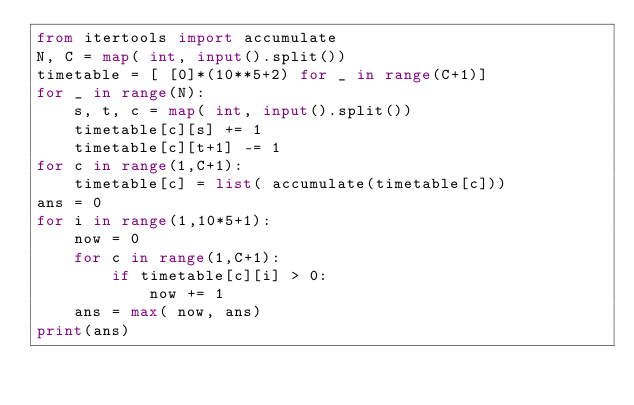Convert code to text. <code><loc_0><loc_0><loc_500><loc_500><_Python_>from itertools import accumulate
N, C = map( int, input().split())
timetable = [ [0]*(10**5+2) for _ in range(C+1)]
for _ in range(N):
    s, t, c = map( int, input().split())
    timetable[c][s] += 1
    timetable[c][t+1] -= 1
for c in range(1,C+1):
    timetable[c] = list( accumulate(timetable[c]))
ans = 0
for i in range(1,10*5+1):
    now = 0
    for c in range(1,C+1):
        if timetable[c][i] > 0:
            now += 1
    ans = max( now, ans)
print(ans)</code> 